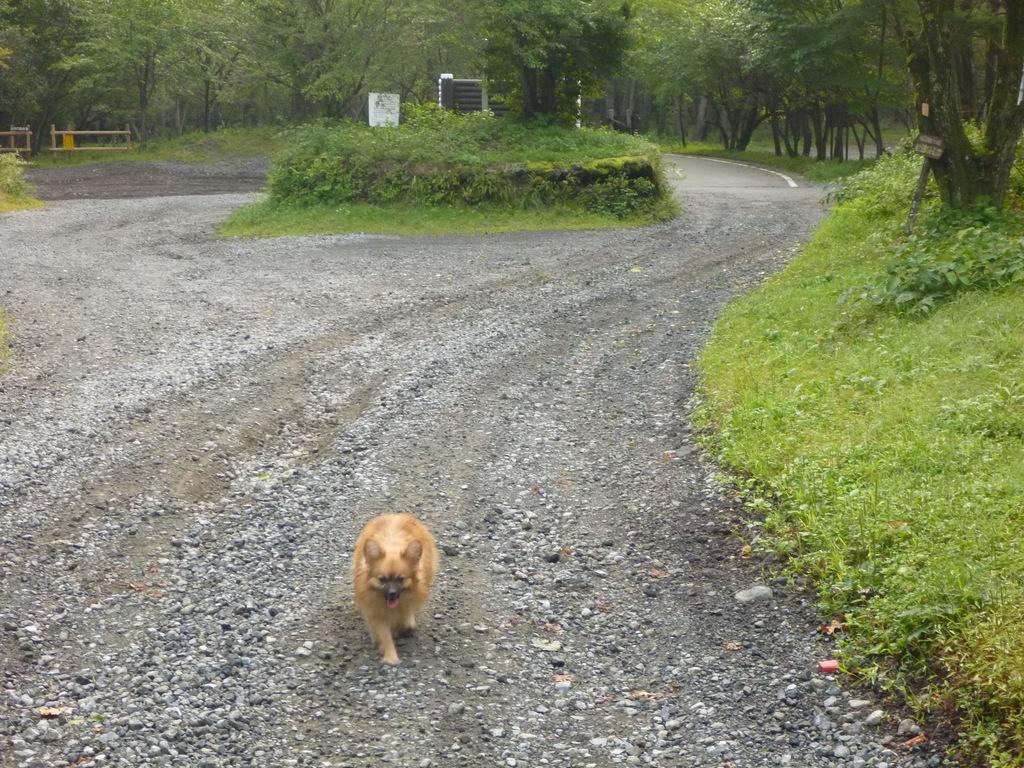Could you give a brief overview of what you see in this image? In this image there is a dog walking on the ground in the center. On the right side there is grass on the ground and there are trees. In the center there is grass on the ground and in the background there are trees, there are barricades and there is an object which is white in colour and there is a stand which is black in colour. 